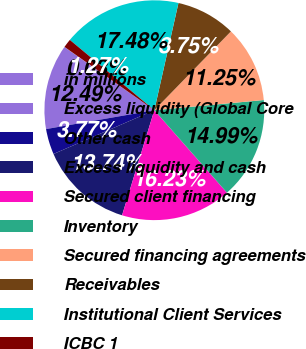Convert chart to OTSL. <chart><loc_0><loc_0><loc_500><loc_500><pie_chart><fcel>in millions<fcel>Excess liquidity (Global Core<fcel>Other cash<fcel>Excess liquidity and cash<fcel>Secured client financing<fcel>Inventory<fcel>Secured financing agreements<fcel>Receivables<fcel>Institutional Client Services<fcel>ICBC 1<nl><fcel>0.03%<fcel>12.49%<fcel>3.77%<fcel>13.74%<fcel>16.23%<fcel>14.99%<fcel>11.25%<fcel>8.75%<fcel>17.48%<fcel>1.27%<nl></chart> 